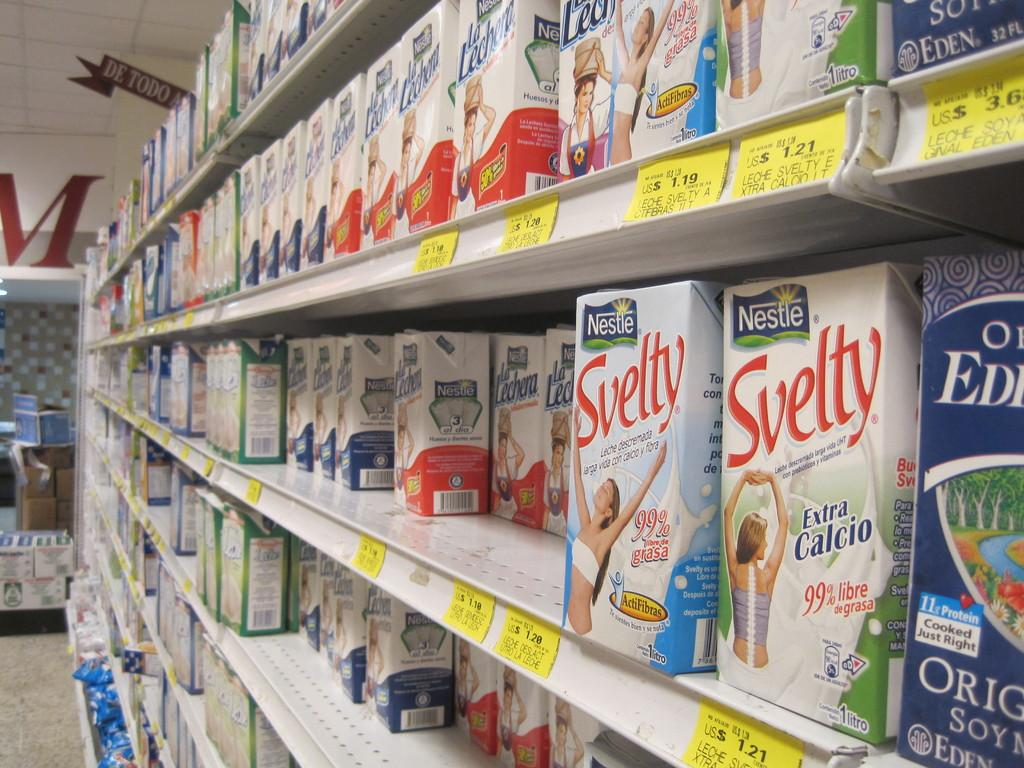Provide a one-sentence caption for the provided image. A grocery isle showing different varieties of milk in a carton from Nestle. 